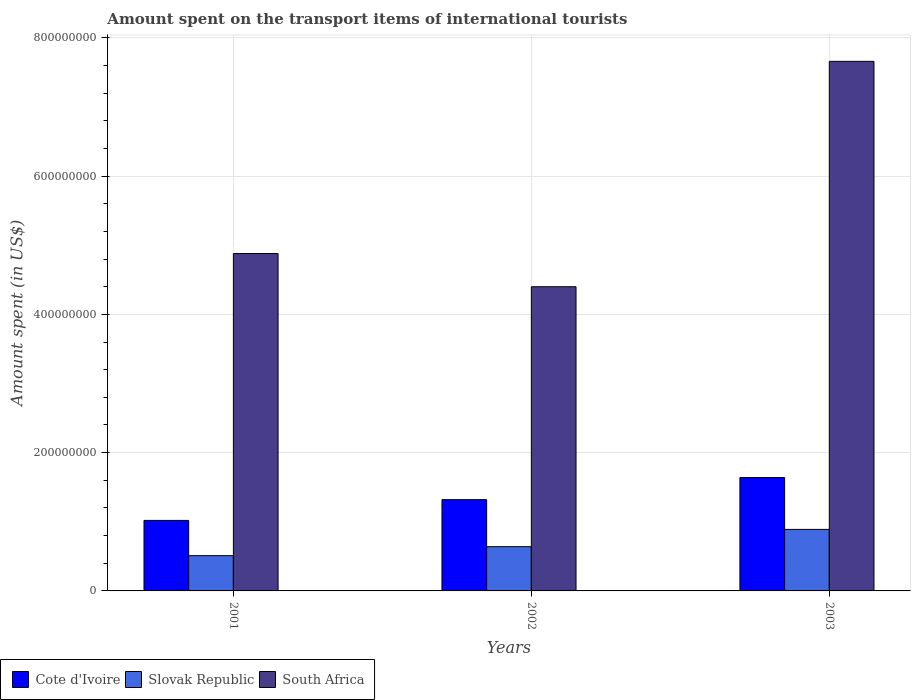How many different coloured bars are there?
Your answer should be compact. 3. How many groups of bars are there?
Provide a short and direct response. 3. Are the number of bars per tick equal to the number of legend labels?
Keep it short and to the point. Yes. Are the number of bars on each tick of the X-axis equal?
Offer a very short reply. Yes. How many bars are there on the 1st tick from the left?
Your answer should be compact. 3. How many bars are there on the 3rd tick from the right?
Your answer should be compact. 3. What is the amount spent on the transport items of international tourists in South Africa in 2003?
Give a very brief answer. 7.66e+08. Across all years, what is the maximum amount spent on the transport items of international tourists in South Africa?
Your response must be concise. 7.66e+08. Across all years, what is the minimum amount spent on the transport items of international tourists in South Africa?
Your answer should be compact. 4.40e+08. In which year was the amount spent on the transport items of international tourists in South Africa maximum?
Provide a succinct answer. 2003. What is the total amount spent on the transport items of international tourists in South Africa in the graph?
Offer a very short reply. 1.69e+09. What is the difference between the amount spent on the transport items of international tourists in Slovak Republic in 2001 and that in 2003?
Ensure brevity in your answer.  -3.80e+07. What is the difference between the amount spent on the transport items of international tourists in South Africa in 2003 and the amount spent on the transport items of international tourists in Cote d'Ivoire in 2002?
Offer a terse response. 6.34e+08. What is the average amount spent on the transport items of international tourists in Cote d'Ivoire per year?
Your response must be concise. 1.33e+08. In the year 2003, what is the difference between the amount spent on the transport items of international tourists in South Africa and amount spent on the transport items of international tourists in Slovak Republic?
Offer a very short reply. 6.77e+08. What is the ratio of the amount spent on the transport items of international tourists in Slovak Republic in 2001 to that in 2002?
Keep it short and to the point. 0.8. What is the difference between the highest and the second highest amount spent on the transport items of international tourists in Slovak Republic?
Offer a very short reply. 2.50e+07. What is the difference between the highest and the lowest amount spent on the transport items of international tourists in Cote d'Ivoire?
Offer a terse response. 6.20e+07. In how many years, is the amount spent on the transport items of international tourists in South Africa greater than the average amount spent on the transport items of international tourists in South Africa taken over all years?
Offer a terse response. 1. What does the 2nd bar from the left in 2003 represents?
Offer a very short reply. Slovak Republic. What does the 2nd bar from the right in 2003 represents?
Give a very brief answer. Slovak Republic. Is it the case that in every year, the sum of the amount spent on the transport items of international tourists in Cote d'Ivoire and amount spent on the transport items of international tourists in South Africa is greater than the amount spent on the transport items of international tourists in Slovak Republic?
Provide a short and direct response. Yes. Are all the bars in the graph horizontal?
Your answer should be very brief. No. What is the difference between two consecutive major ticks on the Y-axis?
Your answer should be very brief. 2.00e+08. Are the values on the major ticks of Y-axis written in scientific E-notation?
Offer a terse response. No. Does the graph contain any zero values?
Your response must be concise. No. How many legend labels are there?
Provide a short and direct response. 3. How are the legend labels stacked?
Keep it short and to the point. Horizontal. What is the title of the graph?
Provide a succinct answer. Amount spent on the transport items of international tourists. What is the label or title of the Y-axis?
Provide a short and direct response. Amount spent (in US$). What is the Amount spent (in US$) of Cote d'Ivoire in 2001?
Ensure brevity in your answer.  1.02e+08. What is the Amount spent (in US$) of Slovak Republic in 2001?
Your answer should be very brief. 5.10e+07. What is the Amount spent (in US$) in South Africa in 2001?
Keep it short and to the point. 4.88e+08. What is the Amount spent (in US$) in Cote d'Ivoire in 2002?
Make the answer very short. 1.32e+08. What is the Amount spent (in US$) of Slovak Republic in 2002?
Give a very brief answer. 6.40e+07. What is the Amount spent (in US$) in South Africa in 2002?
Ensure brevity in your answer.  4.40e+08. What is the Amount spent (in US$) in Cote d'Ivoire in 2003?
Your answer should be compact. 1.64e+08. What is the Amount spent (in US$) in Slovak Republic in 2003?
Your response must be concise. 8.90e+07. What is the Amount spent (in US$) in South Africa in 2003?
Your response must be concise. 7.66e+08. Across all years, what is the maximum Amount spent (in US$) in Cote d'Ivoire?
Give a very brief answer. 1.64e+08. Across all years, what is the maximum Amount spent (in US$) of Slovak Republic?
Your response must be concise. 8.90e+07. Across all years, what is the maximum Amount spent (in US$) in South Africa?
Give a very brief answer. 7.66e+08. Across all years, what is the minimum Amount spent (in US$) of Cote d'Ivoire?
Your answer should be compact. 1.02e+08. Across all years, what is the minimum Amount spent (in US$) of Slovak Republic?
Make the answer very short. 5.10e+07. Across all years, what is the minimum Amount spent (in US$) in South Africa?
Ensure brevity in your answer.  4.40e+08. What is the total Amount spent (in US$) of Cote d'Ivoire in the graph?
Give a very brief answer. 3.98e+08. What is the total Amount spent (in US$) of Slovak Republic in the graph?
Your answer should be compact. 2.04e+08. What is the total Amount spent (in US$) of South Africa in the graph?
Your response must be concise. 1.69e+09. What is the difference between the Amount spent (in US$) in Cote d'Ivoire in 2001 and that in 2002?
Offer a terse response. -3.00e+07. What is the difference between the Amount spent (in US$) in Slovak Republic in 2001 and that in 2002?
Keep it short and to the point. -1.30e+07. What is the difference between the Amount spent (in US$) of South Africa in 2001 and that in 2002?
Offer a very short reply. 4.80e+07. What is the difference between the Amount spent (in US$) of Cote d'Ivoire in 2001 and that in 2003?
Keep it short and to the point. -6.20e+07. What is the difference between the Amount spent (in US$) in Slovak Republic in 2001 and that in 2003?
Keep it short and to the point. -3.80e+07. What is the difference between the Amount spent (in US$) in South Africa in 2001 and that in 2003?
Ensure brevity in your answer.  -2.78e+08. What is the difference between the Amount spent (in US$) of Cote d'Ivoire in 2002 and that in 2003?
Your response must be concise. -3.20e+07. What is the difference between the Amount spent (in US$) in Slovak Republic in 2002 and that in 2003?
Keep it short and to the point. -2.50e+07. What is the difference between the Amount spent (in US$) of South Africa in 2002 and that in 2003?
Give a very brief answer. -3.26e+08. What is the difference between the Amount spent (in US$) in Cote d'Ivoire in 2001 and the Amount spent (in US$) in Slovak Republic in 2002?
Ensure brevity in your answer.  3.80e+07. What is the difference between the Amount spent (in US$) in Cote d'Ivoire in 2001 and the Amount spent (in US$) in South Africa in 2002?
Offer a terse response. -3.38e+08. What is the difference between the Amount spent (in US$) of Slovak Republic in 2001 and the Amount spent (in US$) of South Africa in 2002?
Your answer should be compact. -3.89e+08. What is the difference between the Amount spent (in US$) in Cote d'Ivoire in 2001 and the Amount spent (in US$) in Slovak Republic in 2003?
Offer a terse response. 1.30e+07. What is the difference between the Amount spent (in US$) of Cote d'Ivoire in 2001 and the Amount spent (in US$) of South Africa in 2003?
Your response must be concise. -6.64e+08. What is the difference between the Amount spent (in US$) of Slovak Republic in 2001 and the Amount spent (in US$) of South Africa in 2003?
Give a very brief answer. -7.15e+08. What is the difference between the Amount spent (in US$) in Cote d'Ivoire in 2002 and the Amount spent (in US$) in Slovak Republic in 2003?
Offer a terse response. 4.30e+07. What is the difference between the Amount spent (in US$) in Cote d'Ivoire in 2002 and the Amount spent (in US$) in South Africa in 2003?
Offer a very short reply. -6.34e+08. What is the difference between the Amount spent (in US$) of Slovak Republic in 2002 and the Amount spent (in US$) of South Africa in 2003?
Provide a succinct answer. -7.02e+08. What is the average Amount spent (in US$) in Cote d'Ivoire per year?
Your answer should be very brief. 1.33e+08. What is the average Amount spent (in US$) of Slovak Republic per year?
Give a very brief answer. 6.80e+07. What is the average Amount spent (in US$) of South Africa per year?
Make the answer very short. 5.65e+08. In the year 2001, what is the difference between the Amount spent (in US$) of Cote d'Ivoire and Amount spent (in US$) of Slovak Republic?
Offer a very short reply. 5.10e+07. In the year 2001, what is the difference between the Amount spent (in US$) in Cote d'Ivoire and Amount spent (in US$) in South Africa?
Ensure brevity in your answer.  -3.86e+08. In the year 2001, what is the difference between the Amount spent (in US$) in Slovak Republic and Amount spent (in US$) in South Africa?
Provide a short and direct response. -4.37e+08. In the year 2002, what is the difference between the Amount spent (in US$) of Cote d'Ivoire and Amount spent (in US$) of Slovak Republic?
Give a very brief answer. 6.80e+07. In the year 2002, what is the difference between the Amount spent (in US$) of Cote d'Ivoire and Amount spent (in US$) of South Africa?
Provide a succinct answer. -3.08e+08. In the year 2002, what is the difference between the Amount spent (in US$) in Slovak Republic and Amount spent (in US$) in South Africa?
Provide a short and direct response. -3.76e+08. In the year 2003, what is the difference between the Amount spent (in US$) of Cote d'Ivoire and Amount spent (in US$) of Slovak Republic?
Your answer should be very brief. 7.50e+07. In the year 2003, what is the difference between the Amount spent (in US$) of Cote d'Ivoire and Amount spent (in US$) of South Africa?
Provide a short and direct response. -6.02e+08. In the year 2003, what is the difference between the Amount spent (in US$) of Slovak Republic and Amount spent (in US$) of South Africa?
Offer a terse response. -6.77e+08. What is the ratio of the Amount spent (in US$) of Cote d'Ivoire in 2001 to that in 2002?
Offer a terse response. 0.77. What is the ratio of the Amount spent (in US$) of Slovak Republic in 2001 to that in 2002?
Your answer should be compact. 0.8. What is the ratio of the Amount spent (in US$) of South Africa in 2001 to that in 2002?
Make the answer very short. 1.11. What is the ratio of the Amount spent (in US$) in Cote d'Ivoire in 2001 to that in 2003?
Give a very brief answer. 0.62. What is the ratio of the Amount spent (in US$) in Slovak Republic in 2001 to that in 2003?
Make the answer very short. 0.57. What is the ratio of the Amount spent (in US$) of South Africa in 2001 to that in 2003?
Make the answer very short. 0.64. What is the ratio of the Amount spent (in US$) of Cote d'Ivoire in 2002 to that in 2003?
Offer a very short reply. 0.8. What is the ratio of the Amount spent (in US$) of Slovak Republic in 2002 to that in 2003?
Make the answer very short. 0.72. What is the ratio of the Amount spent (in US$) in South Africa in 2002 to that in 2003?
Offer a terse response. 0.57. What is the difference between the highest and the second highest Amount spent (in US$) in Cote d'Ivoire?
Provide a succinct answer. 3.20e+07. What is the difference between the highest and the second highest Amount spent (in US$) in Slovak Republic?
Keep it short and to the point. 2.50e+07. What is the difference between the highest and the second highest Amount spent (in US$) in South Africa?
Make the answer very short. 2.78e+08. What is the difference between the highest and the lowest Amount spent (in US$) in Cote d'Ivoire?
Your answer should be compact. 6.20e+07. What is the difference between the highest and the lowest Amount spent (in US$) in Slovak Republic?
Provide a short and direct response. 3.80e+07. What is the difference between the highest and the lowest Amount spent (in US$) in South Africa?
Give a very brief answer. 3.26e+08. 